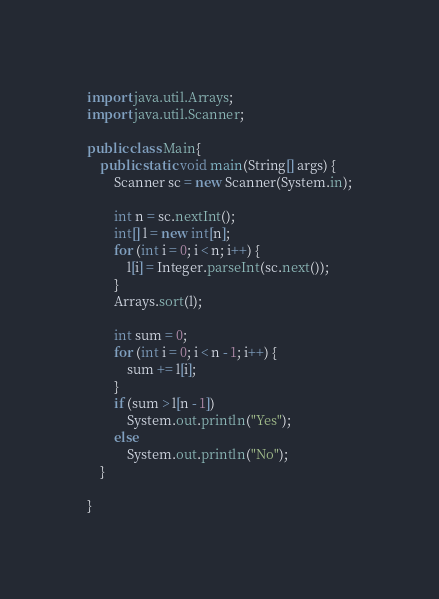<code> <loc_0><loc_0><loc_500><loc_500><_Java_>

import java.util.Arrays;
import java.util.Scanner;

public class Main{
	public static void main(String[] args) {
		Scanner sc = new Scanner(System.in);

		int n = sc.nextInt();
		int[] l = new int[n];
		for (int i = 0; i < n; i++) {
			l[i] = Integer.parseInt(sc.next());
		}
		Arrays.sort(l);

		int sum = 0;
		for (int i = 0; i < n - 1; i++) {
			sum += l[i];
		}
		if (sum > l[n - 1])
			System.out.println("Yes");
		else
			System.out.println("No");
	}

}
</code> 